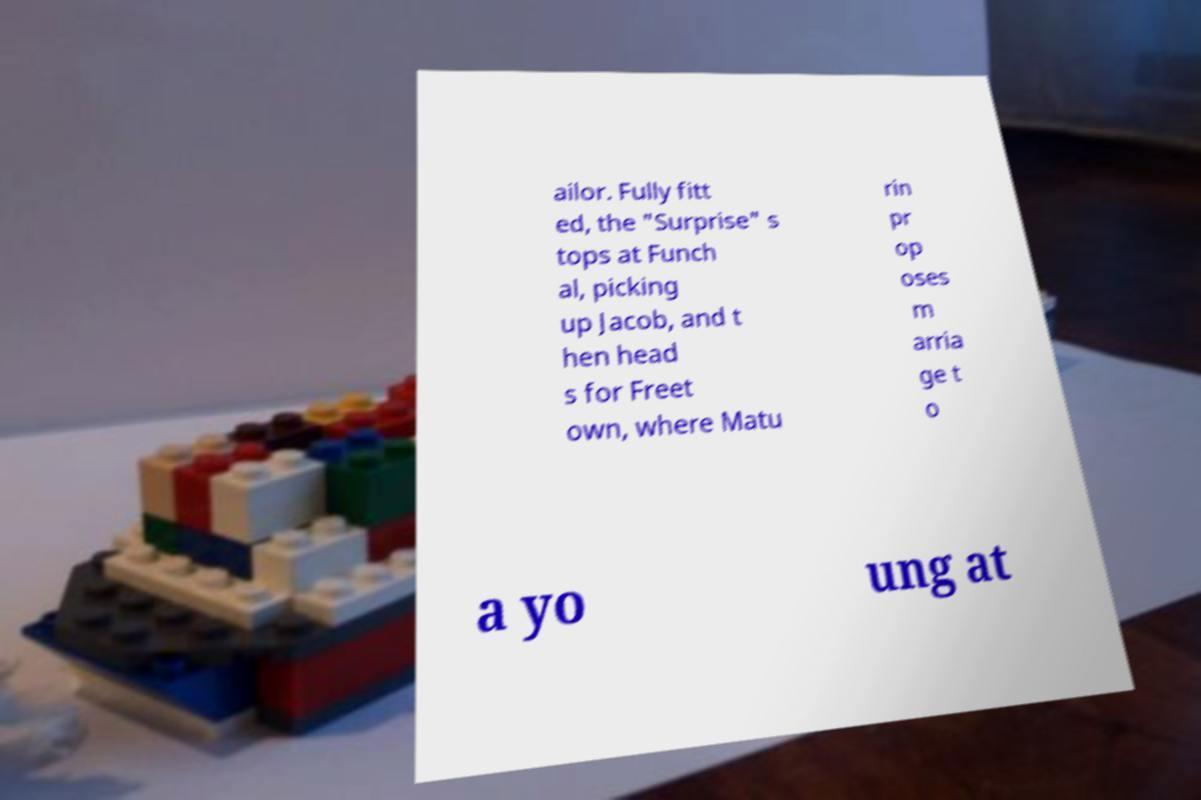Could you assist in decoding the text presented in this image and type it out clearly? ailor. Fully fitt ed, the "Surprise" s tops at Funch al, picking up Jacob, and t hen head s for Freet own, where Matu rin pr op oses m arria ge t o a yo ung at 